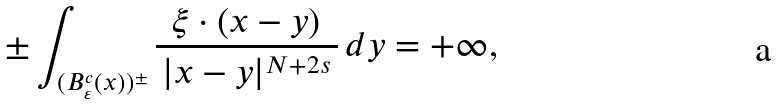Convert formula to latex. <formula><loc_0><loc_0><loc_500><loc_500>\pm \int _ { ( B ^ { c } _ { \varepsilon } ( x ) ) ^ { \pm } } \frac { \xi \cdot ( x - y ) } { \, | x - y | ^ { N + 2 s } \, } \, d y = + \infty ,</formula> 